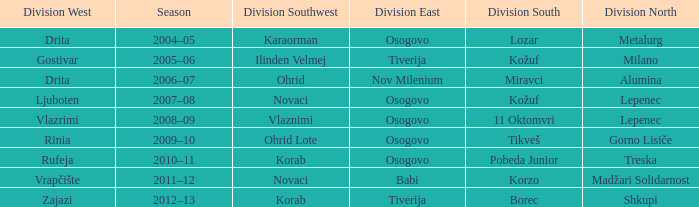Who won Division West when Division North was won by Alumina? Drita. Parse the table in full. {'header': ['Division West', 'Season', 'Division Southwest', 'Division East', 'Division South', 'Division North'], 'rows': [['Drita', '2004–05', 'Karaorman', 'Osogovo', 'Lozar', 'Metalurg'], ['Gostivar', '2005–06', 'Ilinden Velmej', 'Tiverija', 'Kožuf', 'Milano'], ['Drita', '2006–07', 'Ohrid', 'Nov Milenium', 'Miravci', 'Alumina'], ['Ljuboten', '2007–08', 'Novaci', 'Osogovo', 'Kožuf', 'Lepenec'], ['Vlazrimi', '2008–09', 'Vlaznimi', 'Osogovo', '11 Oktomvri', 'Lepenec'], ['Rinia', '2009–10', 'Ohrid Lote', 'Osogovo', 'Tikveš', 'Gorno Lisiče'], ['Rufeja', '2010–11', 'Korab', 'Osogovo', 'Pobeda Junior', 'Treska'], ['Vrapčište', '2011–12', 'Novaci', 'Babi', 'Korzo', 'Madžari Solidarnost'], ['Zajazi', '2012–13', 'Korab', 'Tiverija', 'Borec', 'Shkupi']]} 